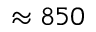<formula> <loc_0><loc_0><loc_500><loc_500>\approx 8 5 0</formula> 